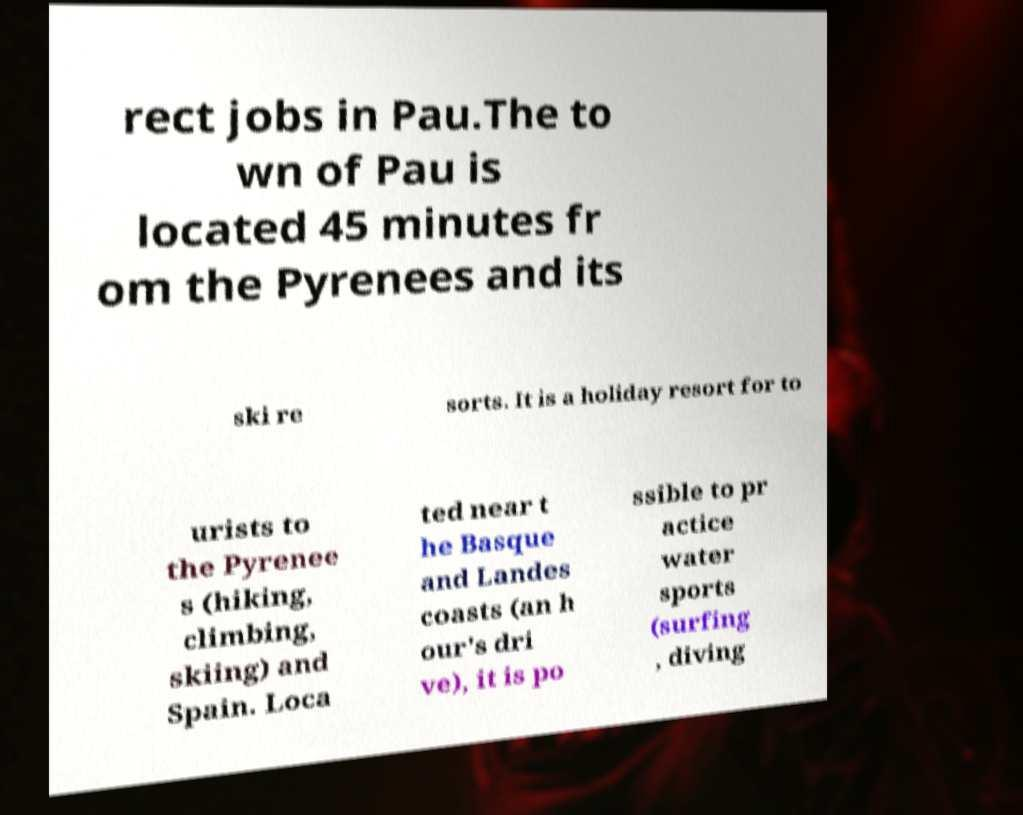There's text embedded in this image that I need extracted. Can you transcribe it verbatim? rect jobs in Pau.The to wn of Pau is located 45 minutes fr om the Pyrenees and its ski re sorts. It is a holiday resort for to urists to the Pyrenee s (hiking, climbing, skiing) and Spain. Loca ted near t he Basque and Landes coasts (an h our's dri ve), it is po ssible to pr actice water sports (surfing , diving 